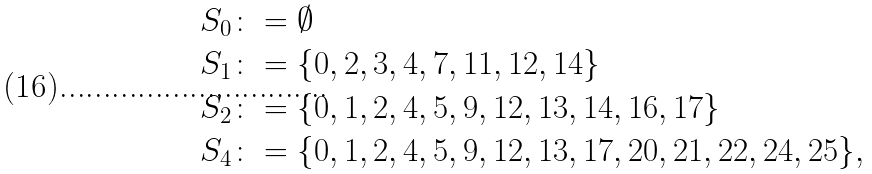<formula> <loc_0><loc_0><loc_500><loc_500>S _ { 0 } & \colon = \emptyset \\ S _ { 1 } & \colon = \{ 0 , 2 , 3 , 4 , 7 , 1 1 , 1 2 , 1 4 \} \\ S _ { 2 } & \colon = \{ 0 , 1 , 2 , 4 , 5 , 9 , 1 2 , 1 3 , 1 4 , 1 6 , 1 7 \} \\ S _ { 4 } & \colon = \{ 0 , 1 , 2 , 4 , 5 , 9 , 1 2 , 1 3 , 1 7 , 2 0 , 2 1 , 2 2 , 2 4 , 2 5 \} ,</formula> 